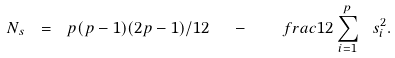<formula> <loc_0><loc_0><loc_500><loc_500>N _ { s } \ = \ p ( p - 1 ) ( 2 p - 1 ) / 1 2 \ \ - \ \ \ f r a c { 1 } { 2 } \sum _ { i = 1 } ^ { p } \ s _ { i } ^ { 2 } .</formula> 